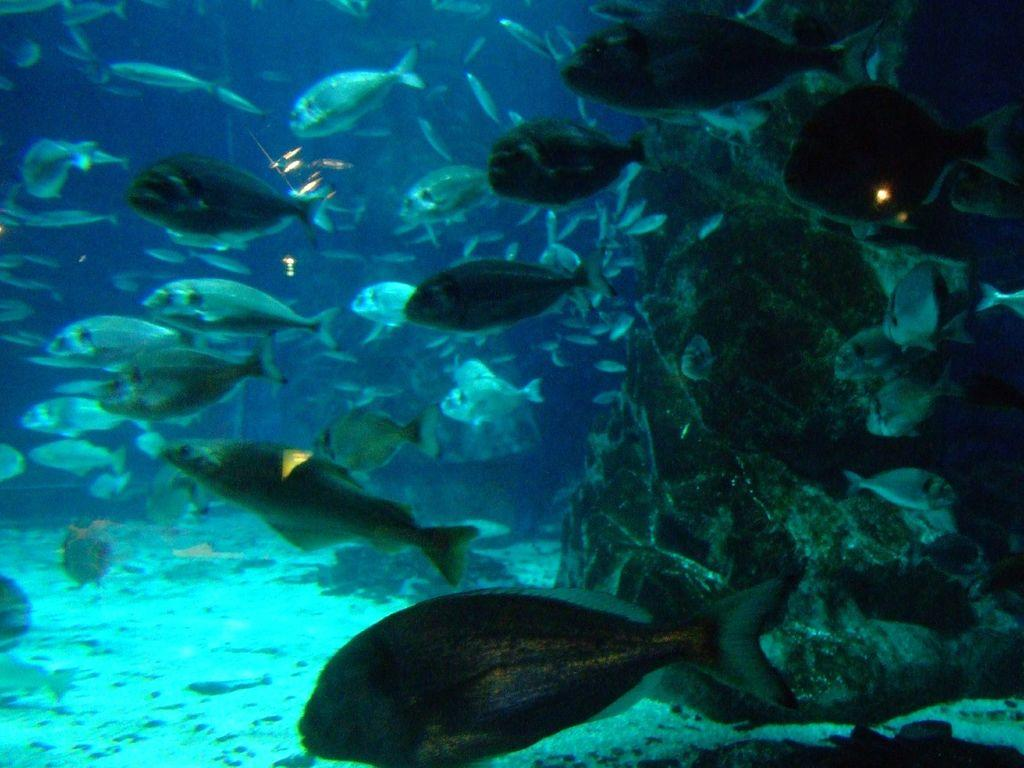What type of environment is shown in the image? The image depicts an underwater scene. What type of marine life can be seen in the image? There are fishes in the image. Are there any other objects or creatures visible in the image besides the fishes? Yes, there are other unspecified objects in the image. What language is the grandmother speaking in the image? There is no grandmother present in the image, as it depicts an underwater scene with fishes and other unspecified objects. 